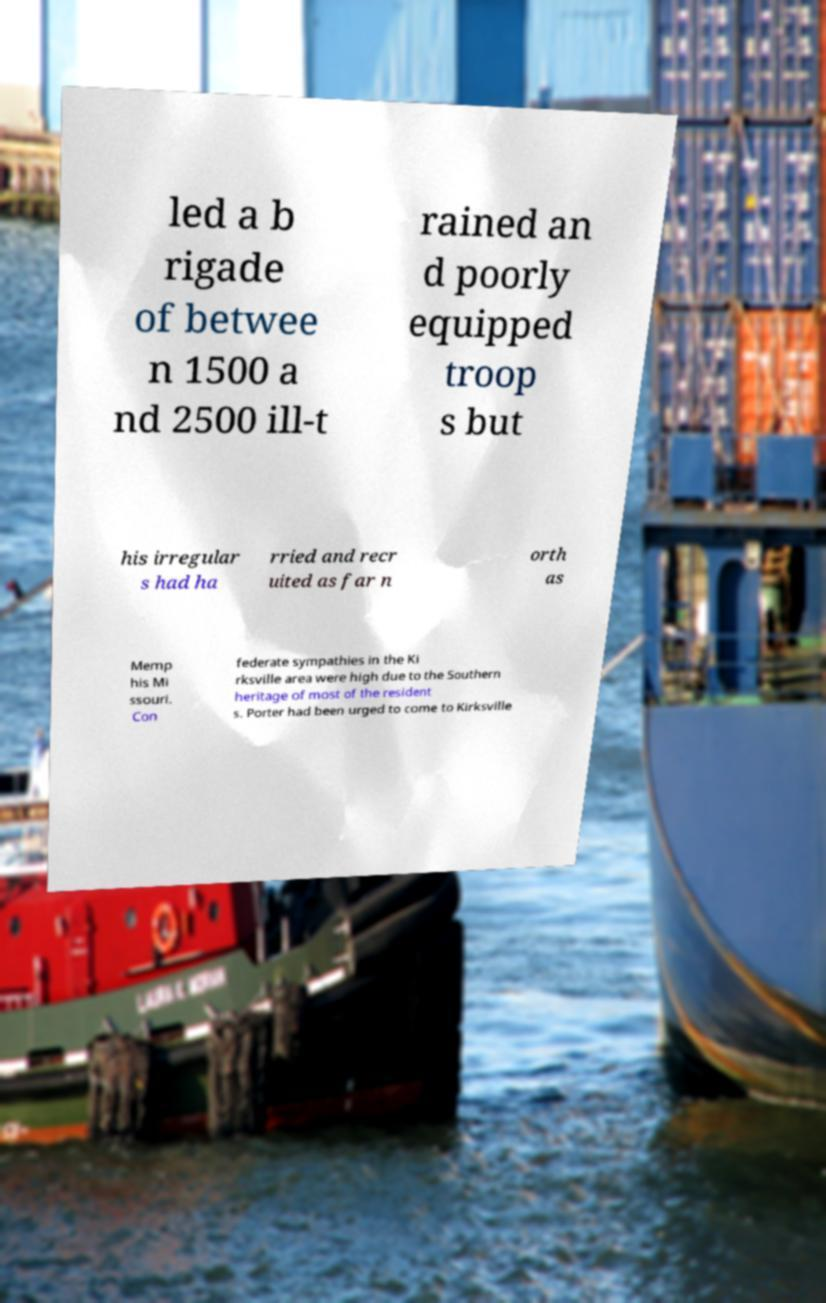For documentation purposes, I need the text within this image transcribed. Could you provide that? led a b rigade of betwee n 1500 a nd 2500 ill-t rained an d poorly equipped troop s but his irregular s had ha rried and recr uited as far n orth as Memp his Mi ssouri. Con federate sympathies in the Ki rksville area were high due to the Southern heritage of most of the resident s. Porter had been urged to come to Kirksville 